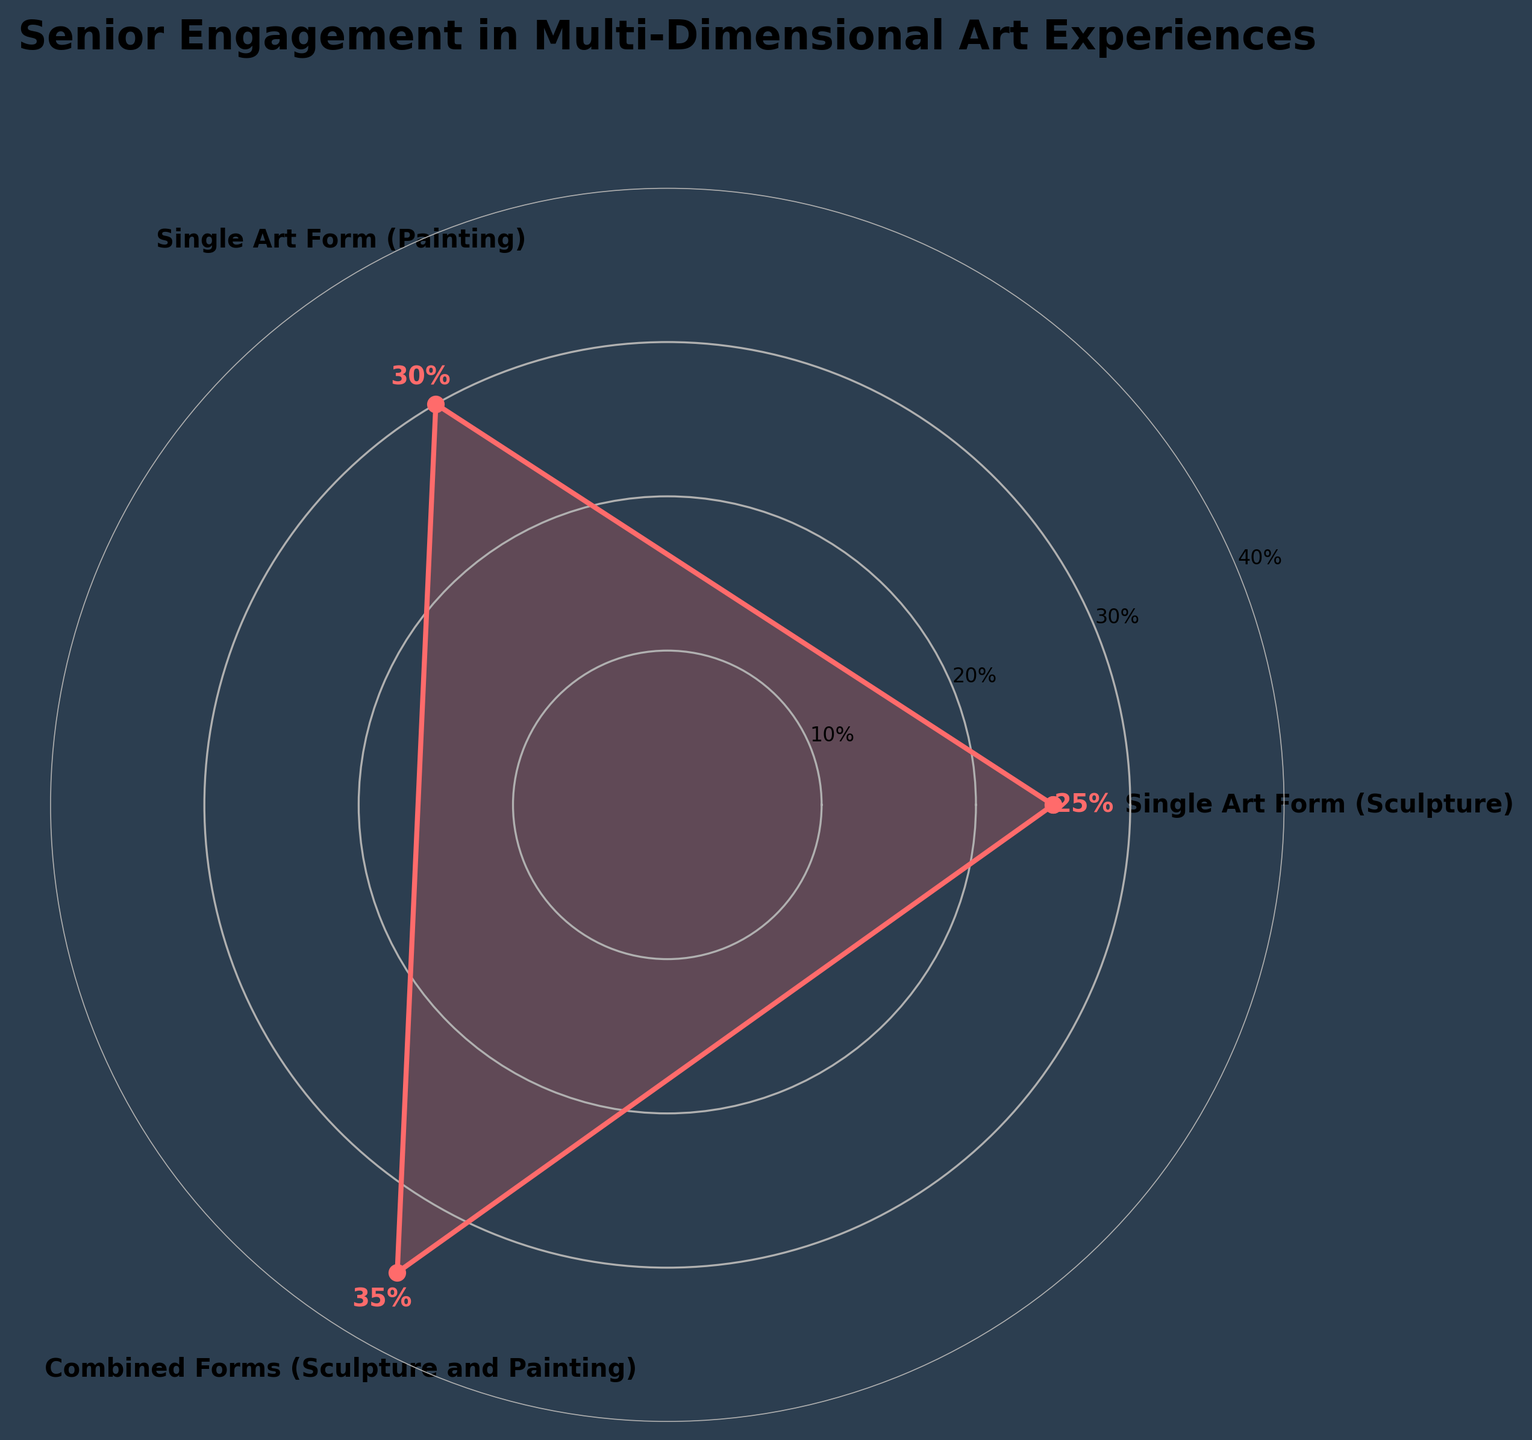What's the title of the chart? The title is written at the top of the chart. It clearly labels what the data is about.
Answer: "Senior Engagement in Multi-Dimensional Art Experiences" How many categories are presented in the figure? By looking at the labels around the perimeter of the chart, you can count the different data points.
Answer: Three Which category has the highest percentage of senior engagement? By comparing the percentages labeled around the chart, you can see which one is the tallest.
Answer: Combined Forms (Sculpture and Painting) What percentage of seniors engage in Single Art Form (Painting)? This is directly labeled on the chart next to the respective category.
Answer: 30% What's the combined percentage of seniors engaging in Single Art Form (both Sculpture and Painting)? Add the percentages of Single Art Form (Sculpture) and Single Art Form (Painting) together: 25% + 30%.
Answer: 55% Which category has a lower engagement percentage, Single Art Form (Sculpture) or Combined Forms (Sculpture and Painting)? By comparing the labels next to these two categories, you can see which is lower.
Answer: Single Art Form (Sculpture) What is the range in the percentage values depicted in this chart? Identify the highest and lowest percentages and find the difference: 35% - 25%.
Answer: 10% What is the average percentage of senior engagement in all categories? Sum the percentages of all categories and divide by the number of categories: (25 + 30 + 35) / 3.
Answer: 30% By how much does the percentage of seniors engaging in Combined Forms (Sculpture and Painting) exceed Single Art Form (Sculpture)? Subtract the percentage of Single Art Form (Sculpture) from Combined Forms (Sculpture and Painting): 35% - 25%.
Answer: 10% What colors are used in the rose chart? The rose chart highlights the segments and the filled areas. They are apparent through visual inspection of the chart.
Answer: Shades of red and dark blue 